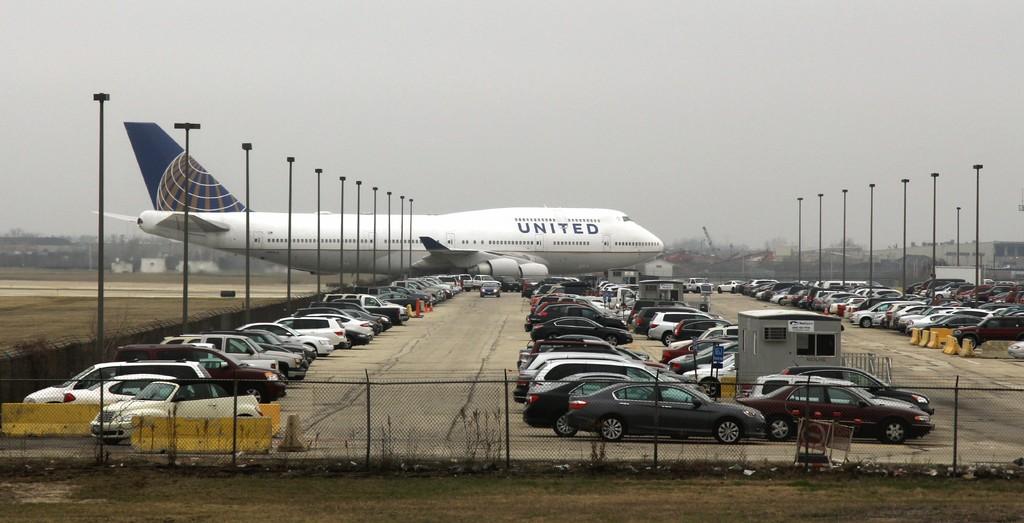What aeroplane is that?
Give a very brief answer. United. What airline is this plane from?
Provide a succinct answer. United. 